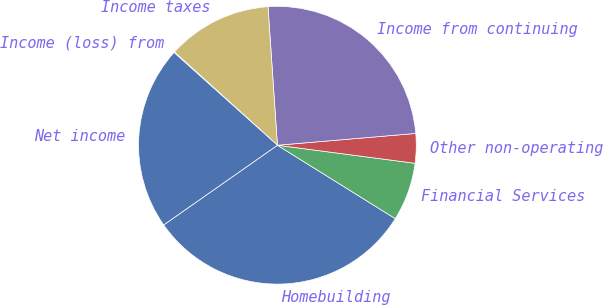Convert chart to OTSL. <chart><loc_0><loc_0><loc_500><loc_500><pie_chart><fcel>Homebuilding<fcel>Financial Services<fcel>Other non-operating<fcel>Income from continuing<fcel>Income taxes<fcel>Income (loss) from<fcel>Net income<nl><fcel>31.41%<fcel>6.79%<fcel>3.43%<fcel>24.73%<fcel>12.22%<fcel>0.07%<fcel>21.37%<nl></chart> 